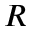Convert formula to latex. <formula><loc_0><loc_0><loc_500><loc_500>R</formula> 